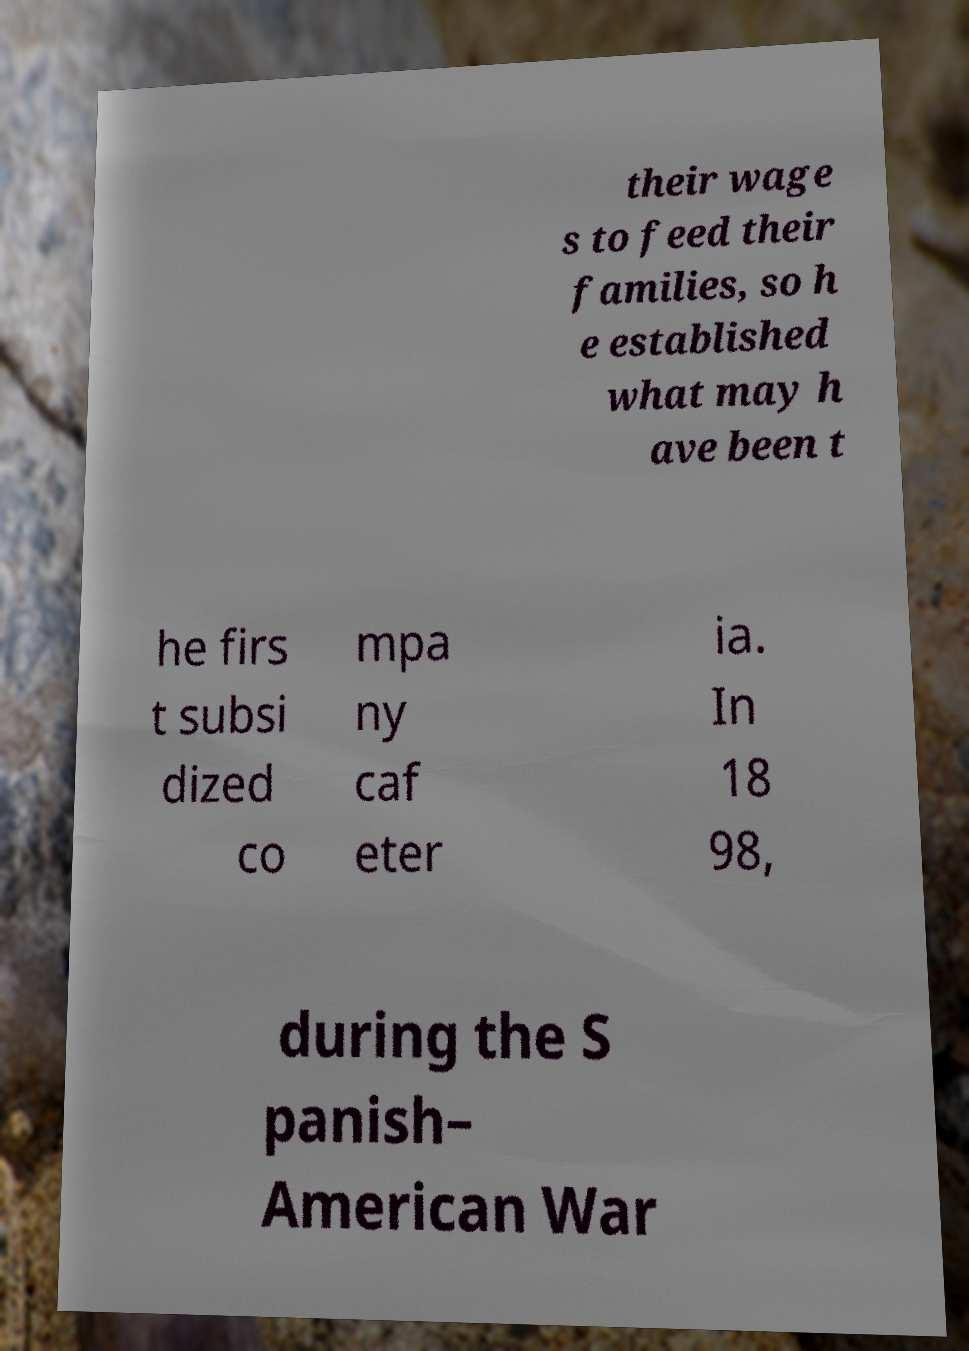Can you read and provide the text displayed in the image?This photo seems to have some interesting text. Can you extract and type it out for me? their wage s to feed their families, so h e established what may h ave been t he firs t subsi dized co mpa ny caf eter ia. In 18 98, during the S panish– American War 